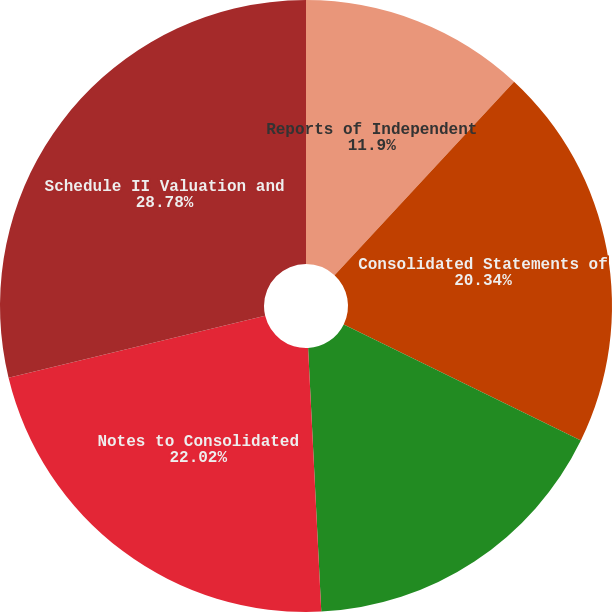Convert chart. <chart><loc_0><loc_0><loc_500><loc_500><pie_chart><fcel>Reports of Independent<fcel>Consolidated Statements of<fcel>Consolidated Balance Sheets at<fcel>Notes to Consolidated<fcel>Schedule II Valuation and<nl><fcel>11.9%<fcel>20.34%<fcel>16.96%<fcel>22.02%<fcel>28.77%<nl></chart> 